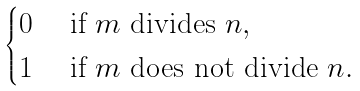<formula> <loc_0><loc_0><loc_500><loc_500>\begin{cases} 0 & \ \text {if $m$ divides $n$} , \\ 1 & \ \text {if $m$ does not divide $n$} . \end{cases}</formula> 